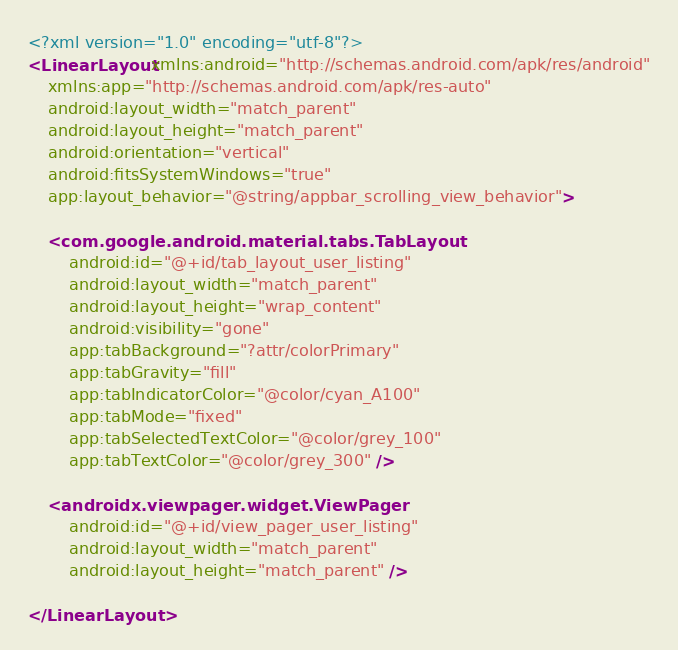Convert code to text. <code><loc_0><loc_0><loc_500><loc_500><_XML_><?xml version="1.0" encoding="utf-8"?>
<LinearLayout xmlns:android="http://schemas.android.com/apk/res/android"
    xmlns:app="http://schemas.android.com/apk/res-auto"
    android:layout_width="match_parent"
    android:layout_height="match_parent"
    android:orientation="vertical"
    android:fitsSystemWindows="true"
    app:layout_behavior="@string/appbar_scrolling_view_behavior">

    <com.google.android.material.tabs.TabLayout
        android:id="@+id/tab_layout_user_listing"
        android:layout_width="match_parent"
        android:layout_height="wrap_content"
        android:visibility="gone"
        app:tabBackground="?attr/colorPrimary"
        app:tabGravity="fill"
        app:tabIndicatorColor="@color/cyan_A100"
        app:tabMode="fixed"
        app:tabSelectedTextColor="@color/grey_100"
        app:tabTextColor="@color/grey_300" />

    <androidx.viewpager.widget.ViewPager
        android:id="@+id/view_pager_user_listing"
        android:layout_width="match_parent"
        android:layout_height="match_parent" />

</LinearLayout>
</code> 